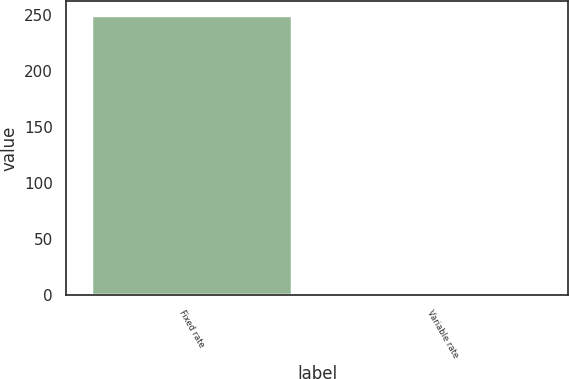Convert chart to OTSL. <chart><loc_0><loc_0><loc_500><loc_500><bar_chart><fcel>Fixed rate<fcel>Variable rate<nl><fcel>250.5<fcel>0.4<nl></chart> 